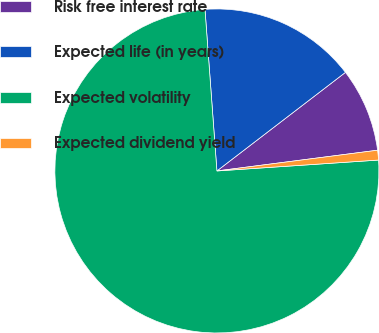Convert chart. <chart><loc_0><loc_0><loc_500><loc_500><pie_chart><fcel>Risk free interest rate<fcel>Expected life (in years)<fcel>Expected volatility<fcel>Expected dividend yield<nl><fcel>8.37%<fcel>15.76%<fcel>74.9%<fcel>0.97%<nl></chart> 